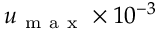<formula> <loc_0><loc_0><loc_500><loc_500>u _ { m a x } \times 1 0 ^ { - 3 }</formula> 